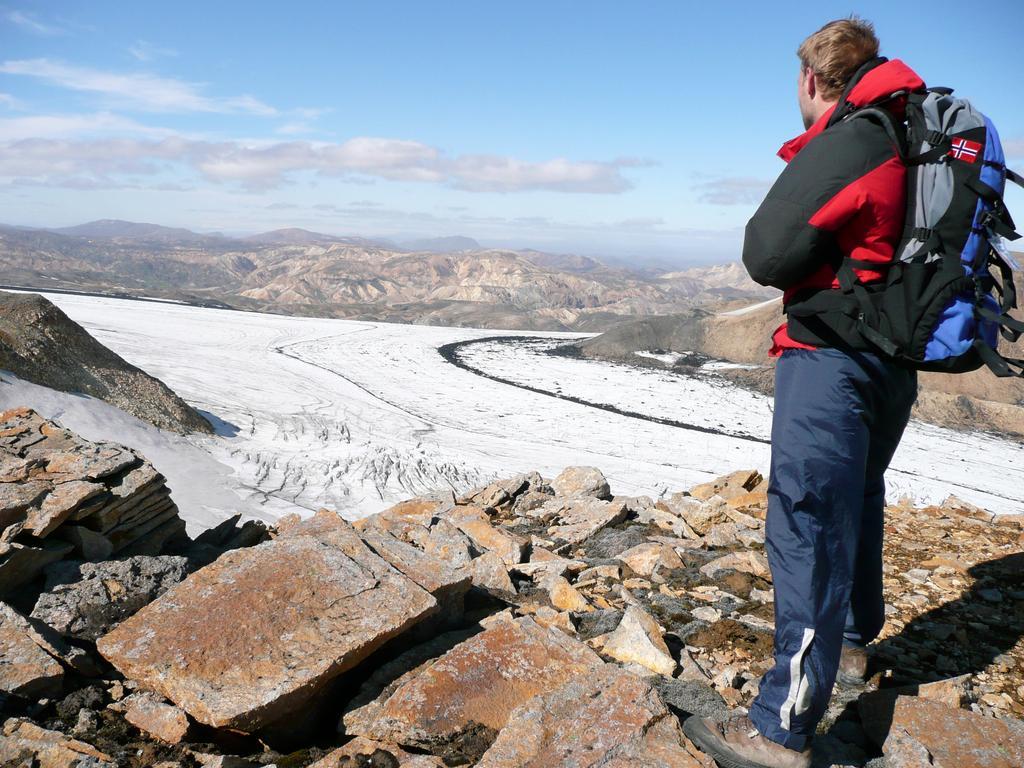How would you summarize this image in a sentence or two? In this picture we can see a man carrying bag worn jacket, shoes and standing on rocks and in front of him we have a path with sand and in the background we can see bottles, sky with clothes. 